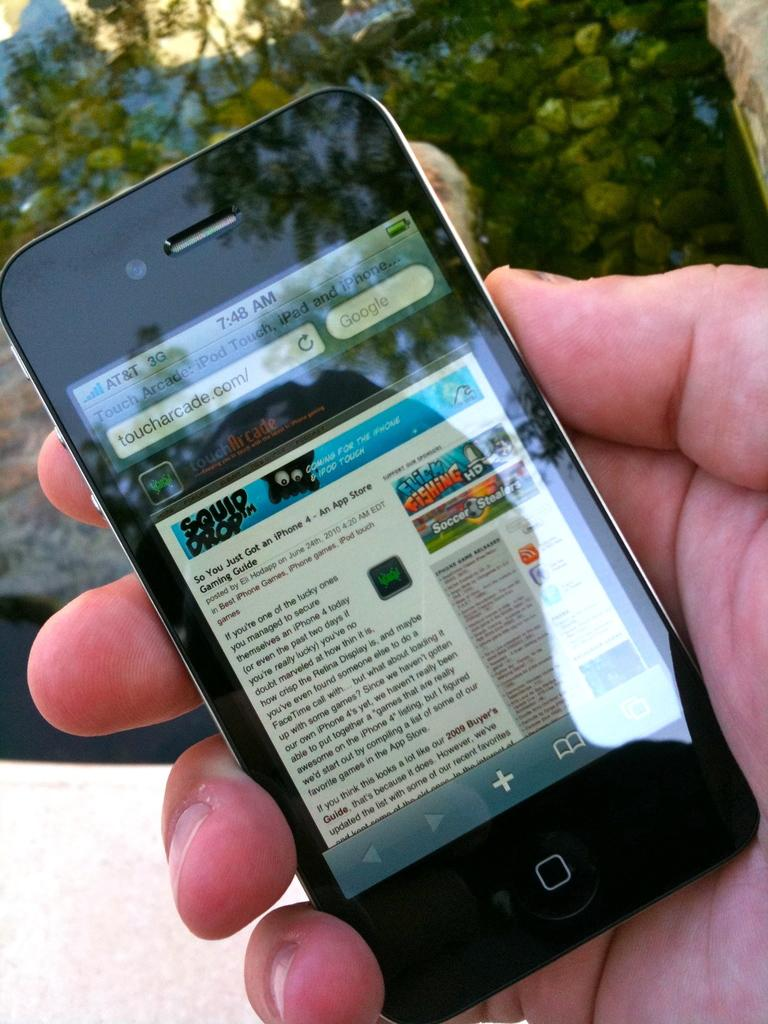What can be seen in the image? There is a person's hand in the image. What is the hand holding? The hand is holding a mobile phone. What type of letter is being written on the sink in the image? There is no sink or letter present in the image; it only features a person's hand holding a mobile phone. 